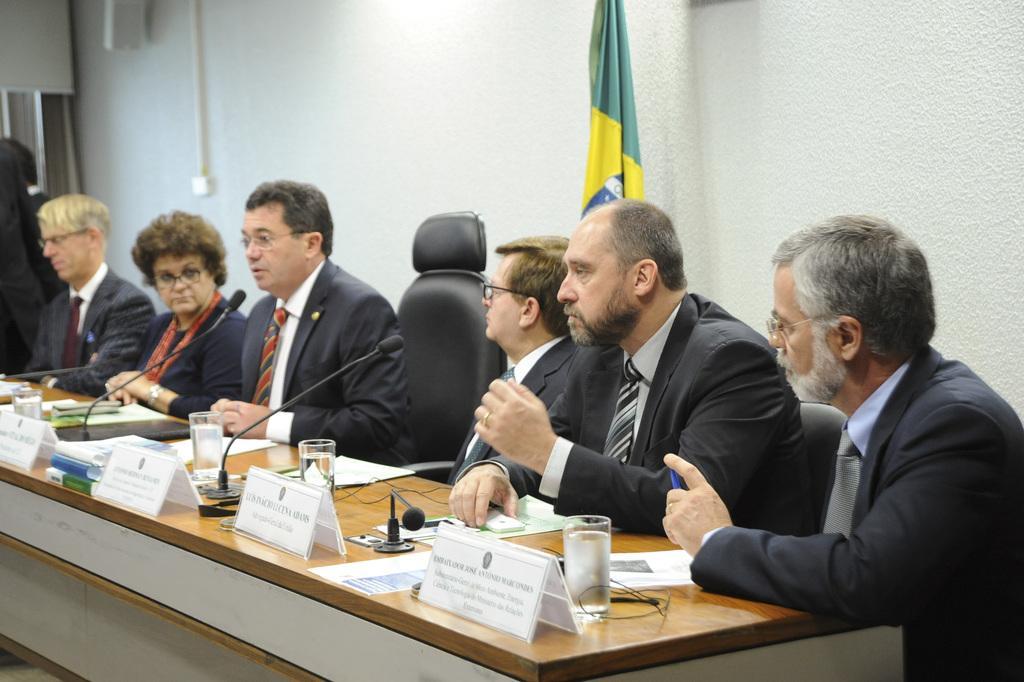Please provide a concise description of this image. On the background we can see a wall and flag. Here we can see all the persons sitting on chairs in front of a table and on the table we can see mikes, water glasses, boards. 